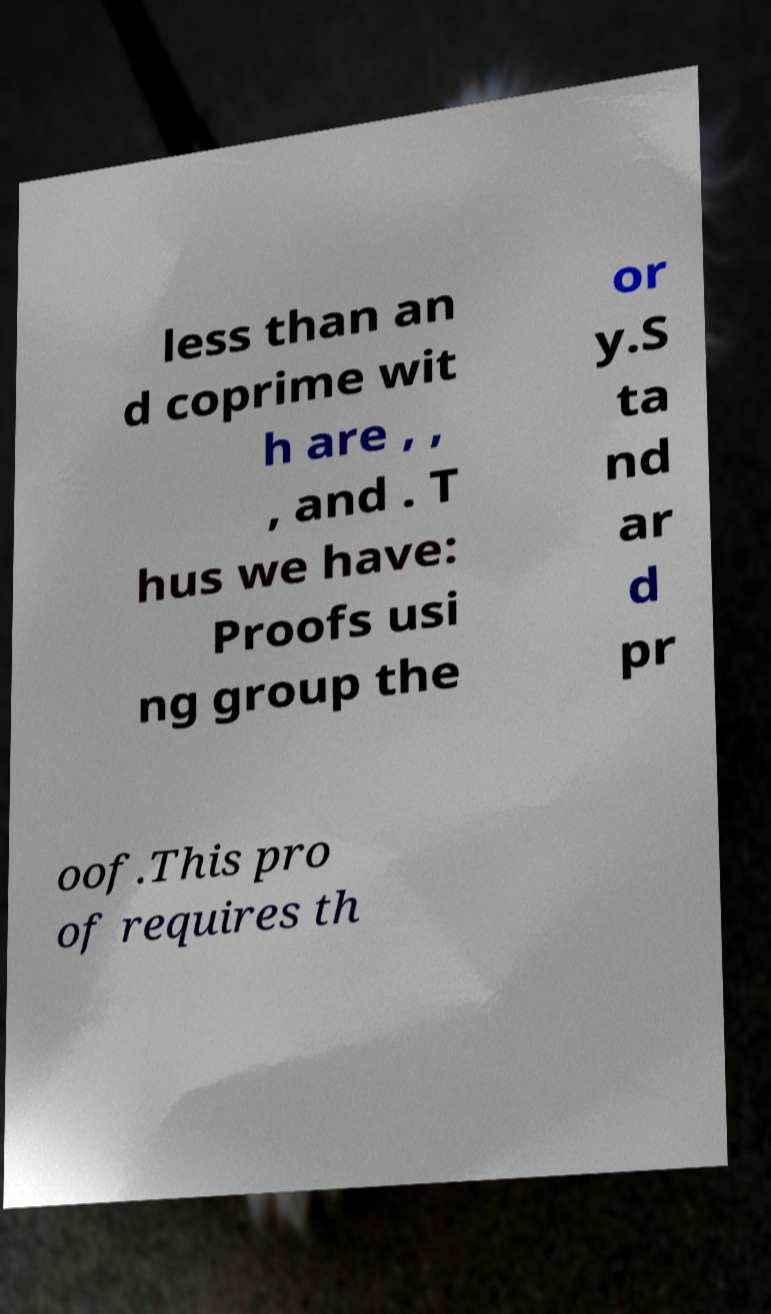There's text embedded in this image that I need extracted. Can you transcribe it verbatim? less than an d coprime wit h are , , , and . T hus we have: Proofs usi ng group the or y.S ta nd ar d pr oof.This pro of requires th 